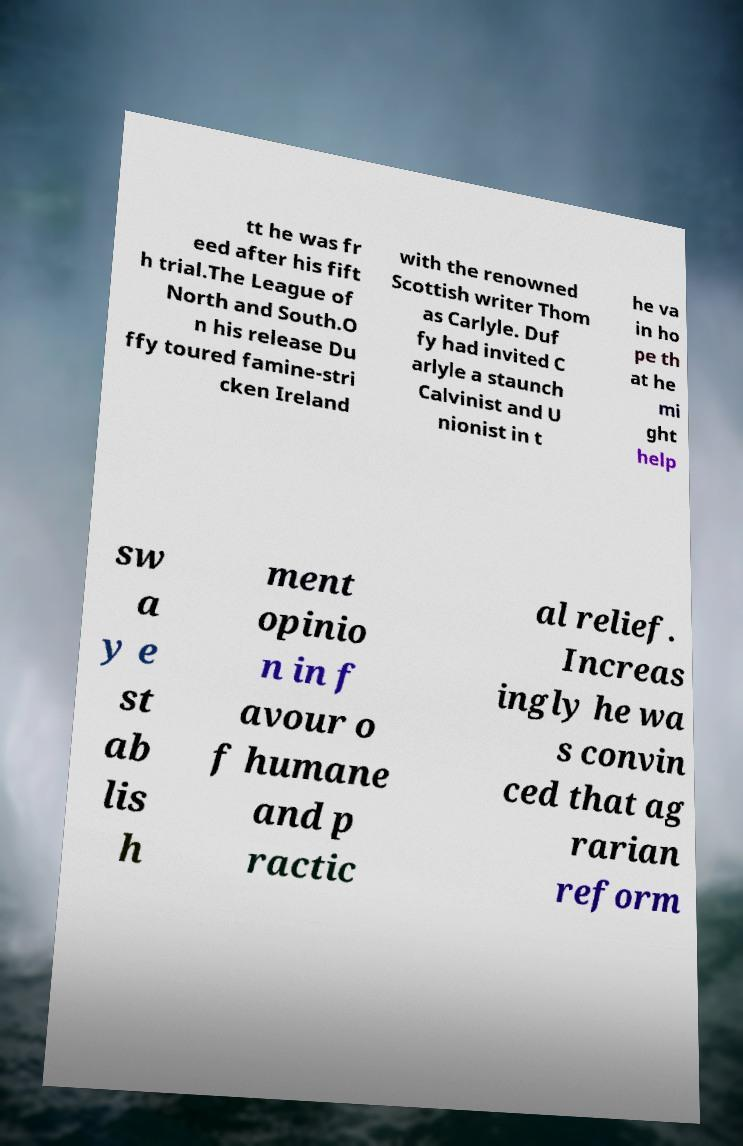I need the written content from this picture converted into text. Can you do that? tt he was fr eed after his fift h trial.The League of North and South.O n his release Du ffy toured famine-stri cken Ireland with the renowned Scottish writer Thom as Carlyle. Duf fy had invited C arlyle a staunch Calvinist and U nionist in t he va in ho pe th at he mi ght help sw a y e st ab lis h ment opinio n in f avour o f humane and p ractic al relief. Increas ingly he wa s convin ced that ag rarian reform 